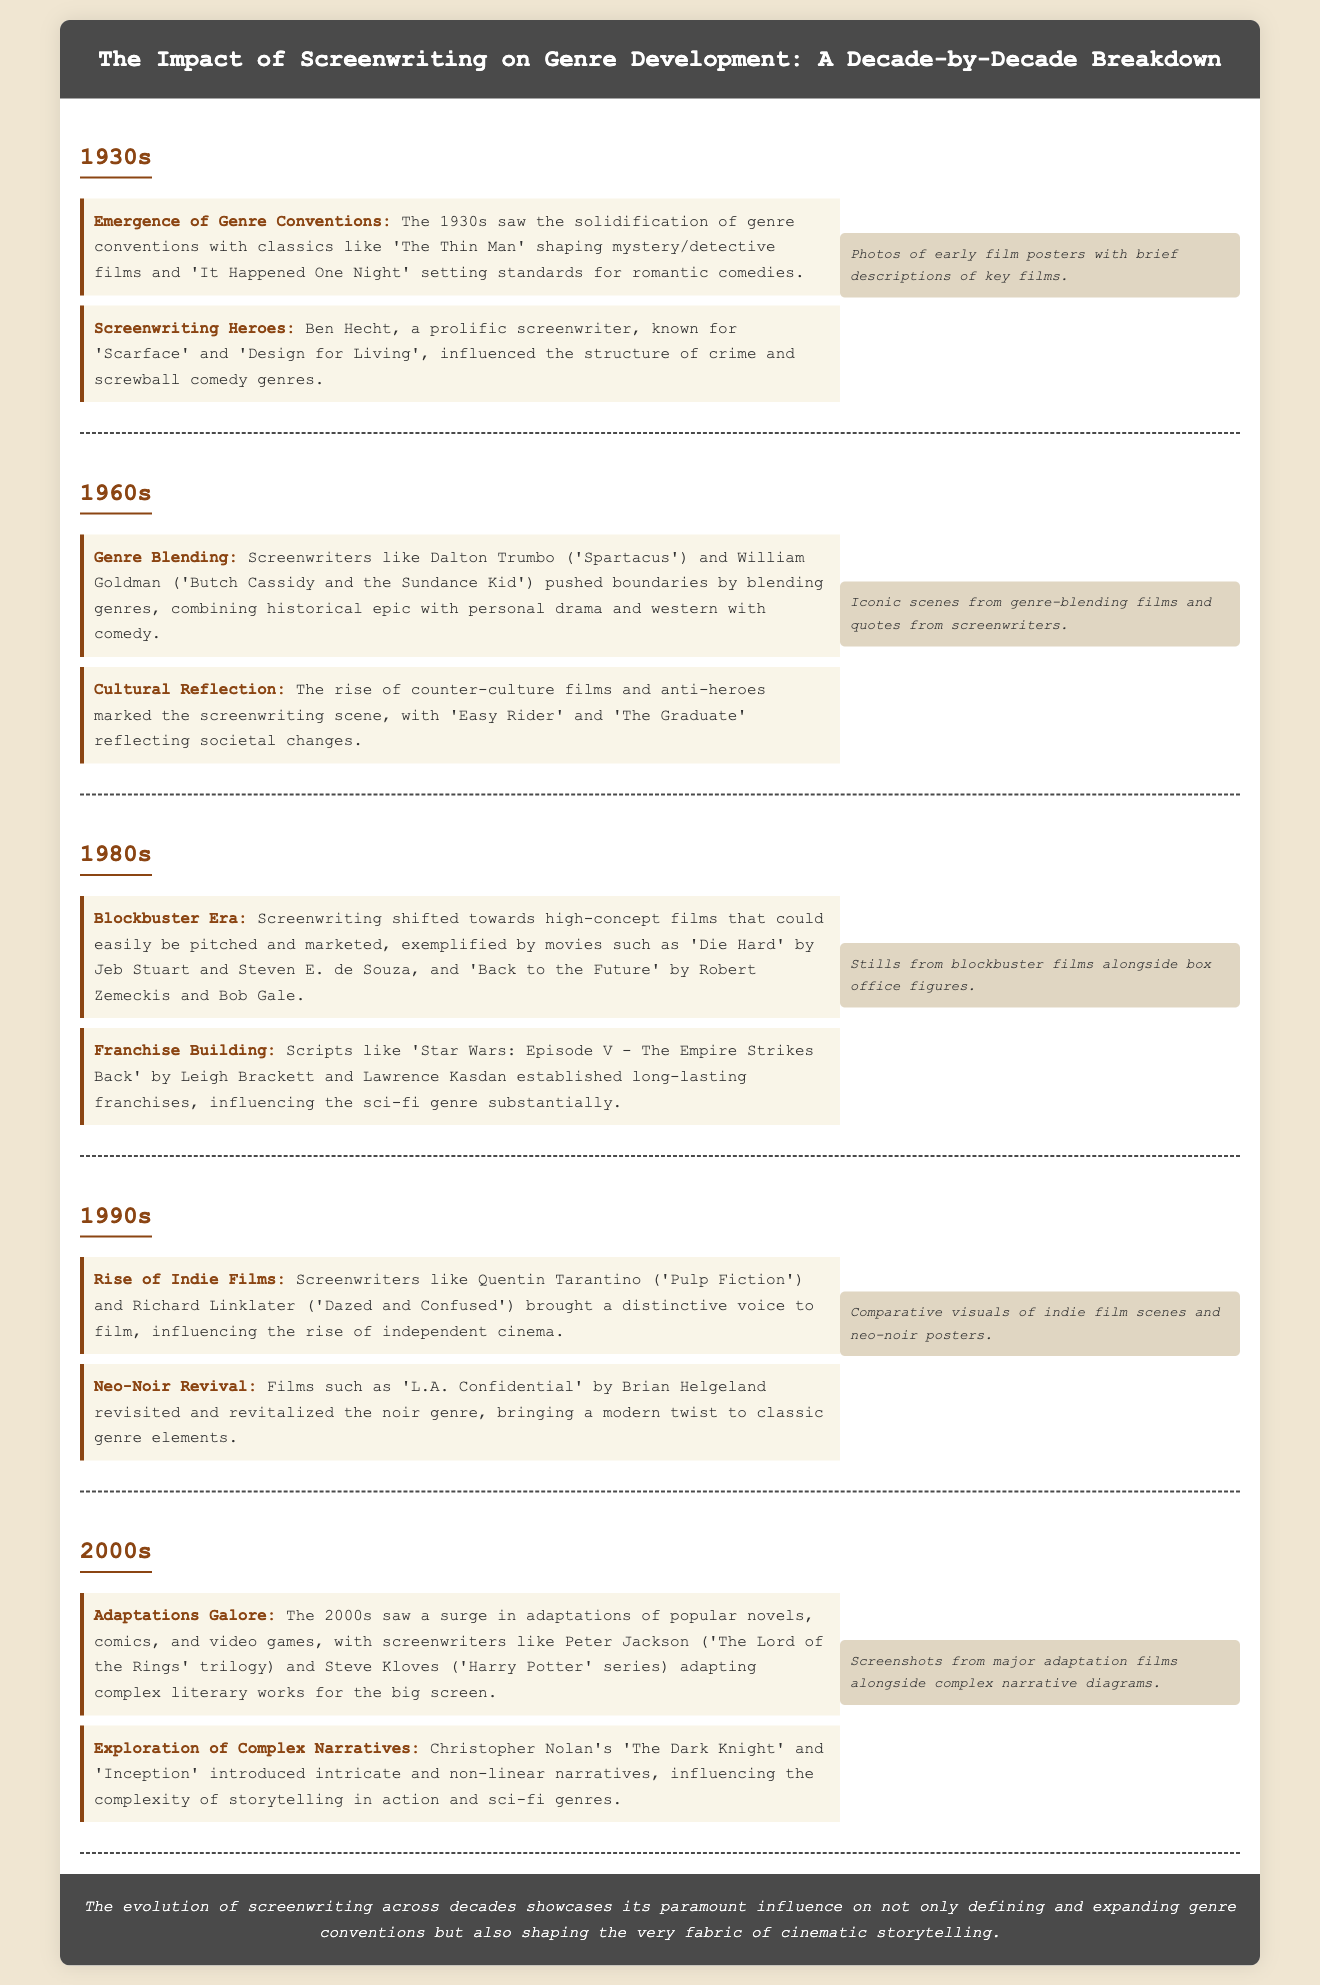What key films shaped the mystery genre in the 1930s? The document mentions 'The Thin Man' as a key film that shaped the mystery/detective genre in the 1930s.
Answer: The Thin Man Who was a prominent screenwriter in the 1930s known for crime films? Ben Hecht is noted in the document as a prolific screenwriter influencing crime genres.
Answer: Ben Hecht What decade is marked by the blockbuster era? According to the text, the 1980s is identified as the blockbuster era in the evolution of screenwriting.
Answer: 1980s Which film is associated with the rise of indie films in the 1990s? The document highlights 'Pulp Fiction' by Quentin Tarantino as a key film contributing to the rise of independent cinema.
Answer: Pulp Fiction What significant trend emerged in the 2000s regarding adaptations? The document states that the 2000s saw a surge in adaptations of novels, comics, and video games.
Answer: Adaptations Which screenwriter introduced complex narratives in the 2000s? Christopher Nolan is mentioned in the document for introducing complex narratives, particularly in 'The Dark Knight' and 'Inception'.
Answer: Christopher Nolan What is the main theme of the document? The conclusion of the document summarizes the influence of screenwriting on genre conventions and cinematic storytelling.
Answer: Influence of screenwriting Which decade experienced genre blending with counter-culture films? The 1960s is highlighted for its genre blending and counter-culture films such as 'Easy Rider' and 'The Graduate'.
Answer: 1960s What genre saw a revival in the 1990s? The neo-noir genre is noted in the document as being revitalized in the 1990s.
Answer: Neo-Noir 